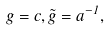Convert formula to latex. <formula><loc_0><loc_0><loc_500><loc_500>g = c , \tilde { g } = a ^ { - 1 } ,</formula> 